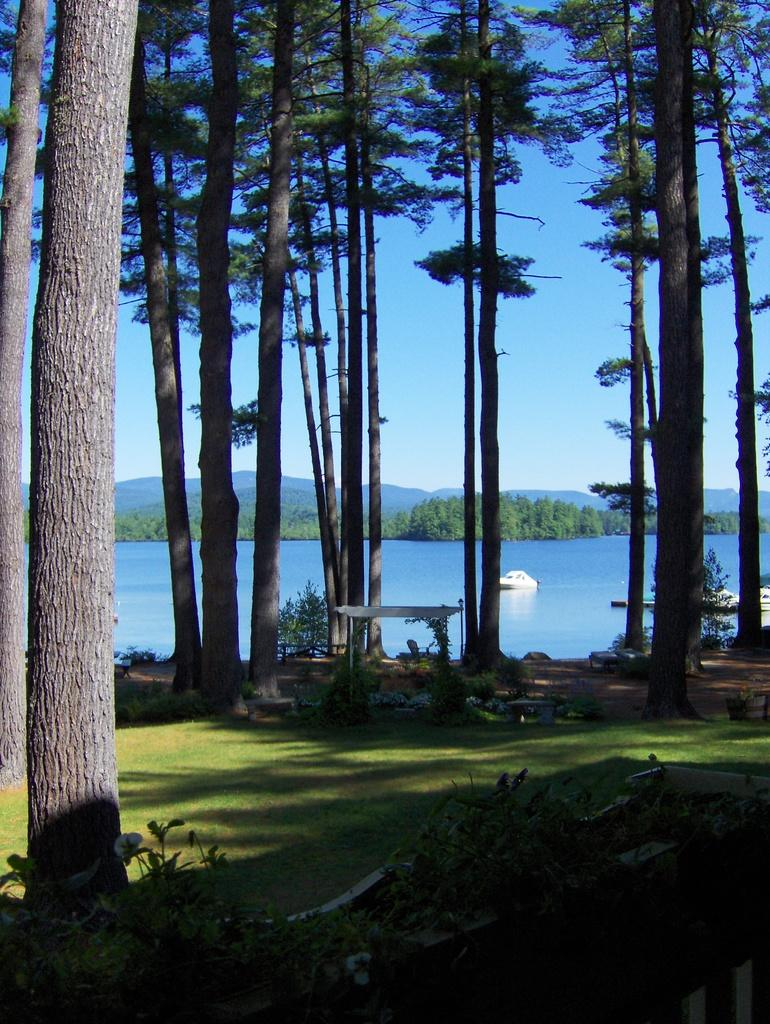What type of vegetation can be seen in the image? There are plants, grass, and trees visible in the image. What is the primary natural element in the foreground of the image? The primary natural element in the foreground is grass. What can be seen in the background of the image? There are ships visible above the water and the sky is visible in the background of the image. How many rods are being used by the boys in the image? There are no rods or boys present in the image. What type of farm can be seen in the image? There is no farm present in the image; it features plants, grass, trees, ships, and the sky. 